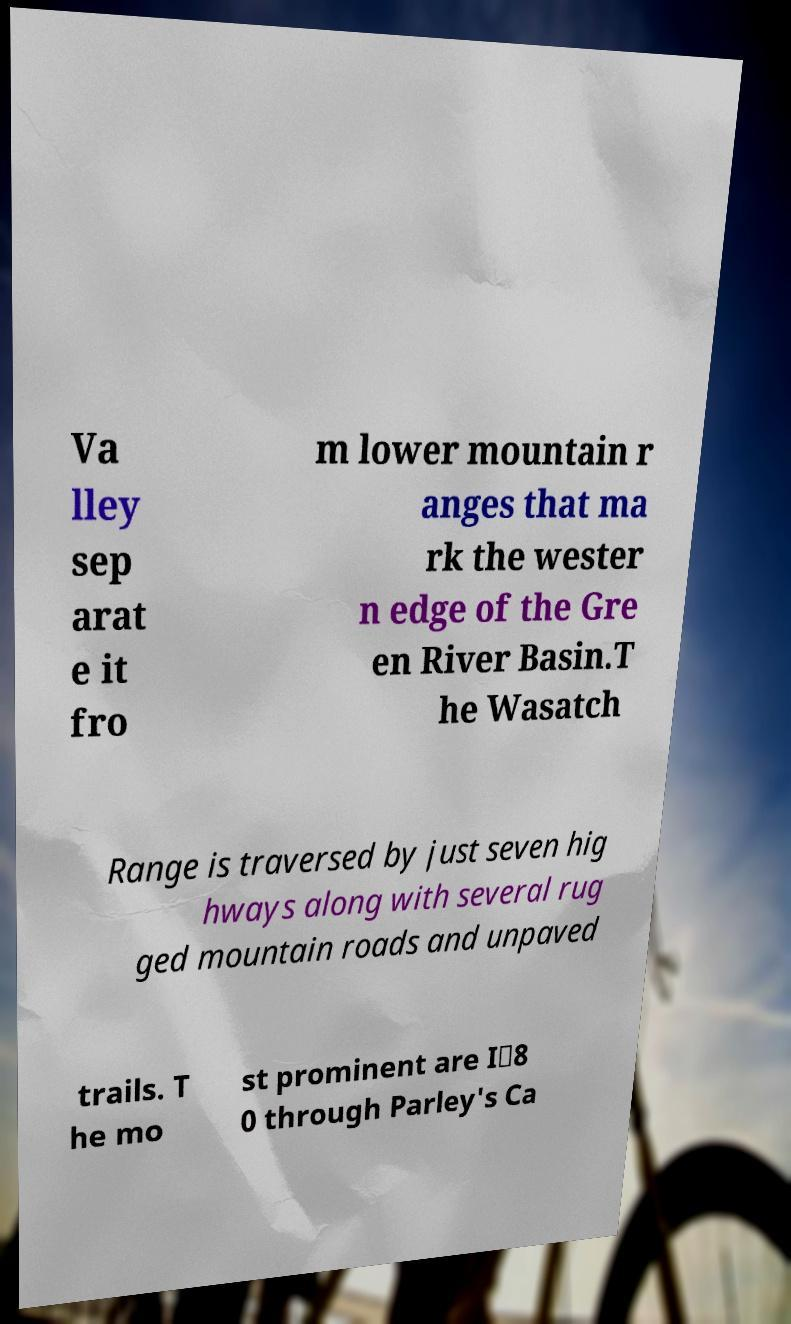There's text embedded in this image that I need extracted. Can you transcribe it verbatim? Va lley sep arat e it fro m lower mountain r anges that ma rk the wester n edge of the Gre en River Basin.T he Wasatch Range is traversed by just seven hig hways along with several rug ged mountain roads and unpaved trails. T he mo st prominent are I‑8 0 through Parley's Ca 